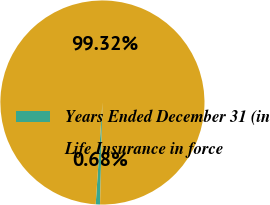<chart> <loc_0><loc_0><loc_500><loc_500><pie_chart><fcel>Years Ended December 31 (in<fcel>Life Insurance in force<nl><fcel>0.68%<fcel>99.32%<nl></chart> 